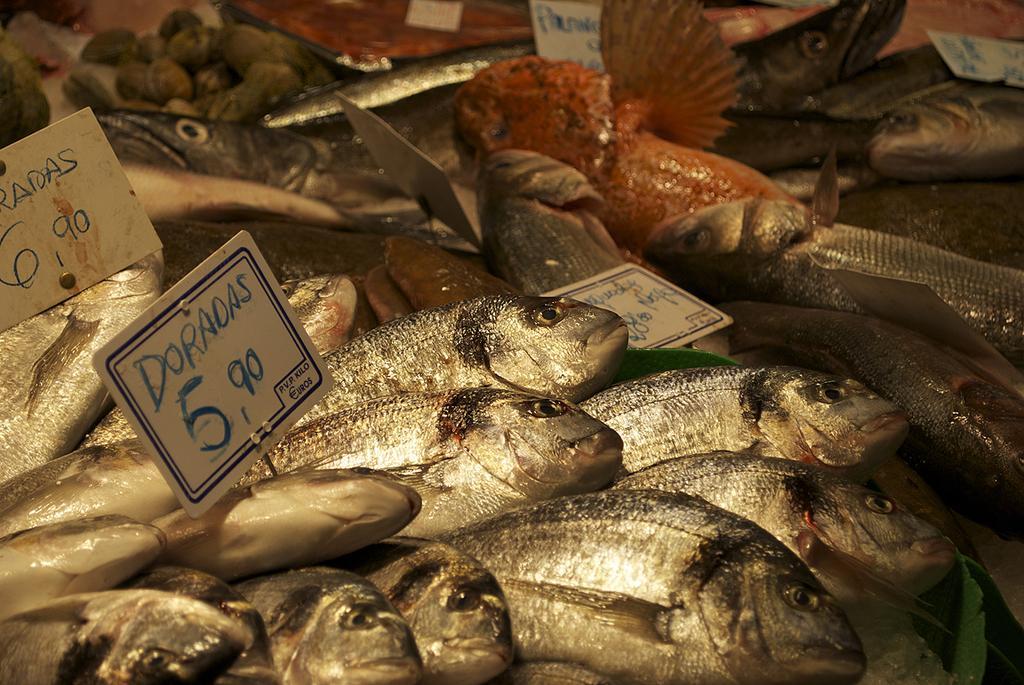Could you give a brief overview of what you see in this image? In the foreground of this image, there are fish and price tags. At the top, it seems like food. 